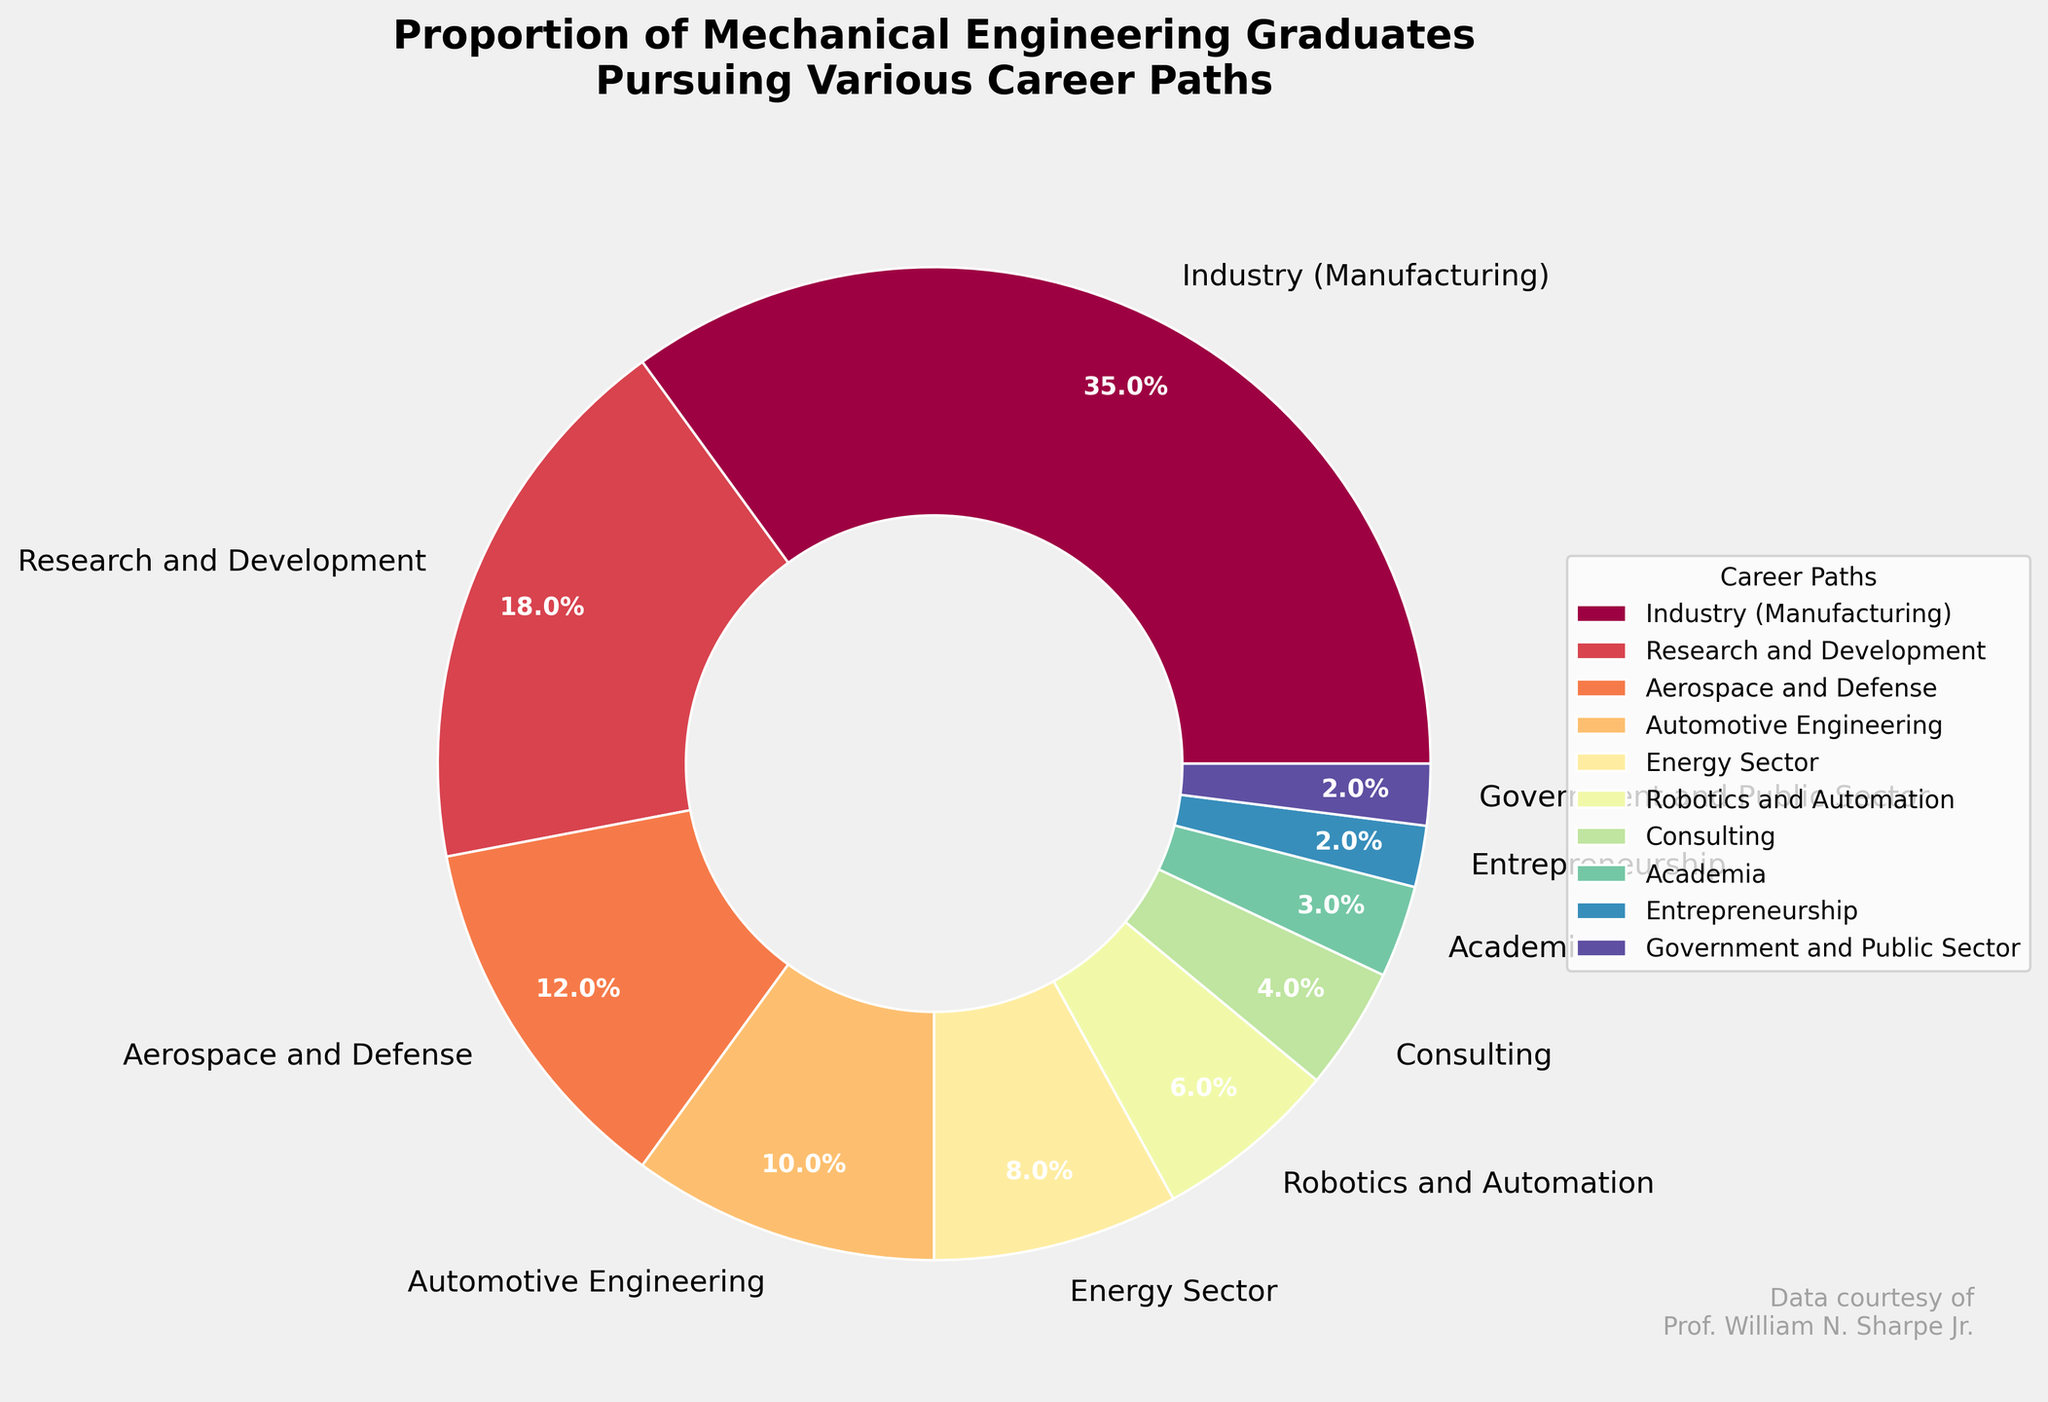Which career path has the highest percentage of graduates? The pie chart shows the proportion of mechanical engineering graduates pursuing various career paths. The largest segment of the pie represents the career path with the highest percentage.
Answer: Industry (Manufacturing) What is the total percentage of graduates in Research and Development and Academia combined? The chart shows that Research and Development has 18% and Academia has 3%. Adding these percentages gives us the total. 18% + 3% = 21%
Answer: 21% Which two career paths have the smallest percentages of graduates? The two smallest segments in the pie chart represent the career paths with the lowest percentages. These are Entrepreneurship and Government and Public Sector, each with 2%.
Answer: Entrepreneurship and Government and Public Sector How many more graduates pursue careers in Industry (Manufacturing) compared to those in Automotive Engineering? The pie chart shows that Industry (Manufacturing) has 35% and Automotive Engineering has 10%. Subtracting these percentages gives the difference. 35% - 10% = 25%
Answer: 25% What percentage of graduates pursue careers in Aerospace and Defense? The pie chart includes a segment for Aerospace and Defense, which represents 12% of the graduates.
Answer: 12% Which career path has a greater percentage: Energy Sector or Robotics and Automation? By comparing the size of the segments in the pie chart, we see that Energy Sector is 8% and Robotics and Automation is 6%. 8% is greater than 6%.
Answer: Energy Sector What is the combined percentage of graduates in Consulting and Entrepreneurship? The pie chart shows that Consulting has 4% and Entrepreneurship has 2%. Adding these percentages gives the combined total. 4% + 2% = 6%
Answer: 6% How many career paths have a percentage of graduates below 5%? By looking at the pie chart, we identify the segments with percentages below 5%. These are Consulting (4%), Academia (3%), Entrepreneurship (2%), and Government and Public Sector (2%). Thus, there are four paths.
Answer: 4 What is the difference in percentage between graduates in Robotics and Automation and those in the Energy Sector? According to the chart, Robotics and Automation has 6% and Energy Sector has 8%. Subtracting these gives the difference. 8% - 6% = 2%
Answer: 2% Which career paths take up more than half of the total graduates combined? Summing up the top segments until we reach 50% or more: Industry (Manufacturing) 35%, Research and Development 18%, and Aerospace and Defense 12%. 35% + 18% + 12% = 65%, which is more than half.
Answer: Industry (Manufacturing), Research and Development, Aerospace and Defense 